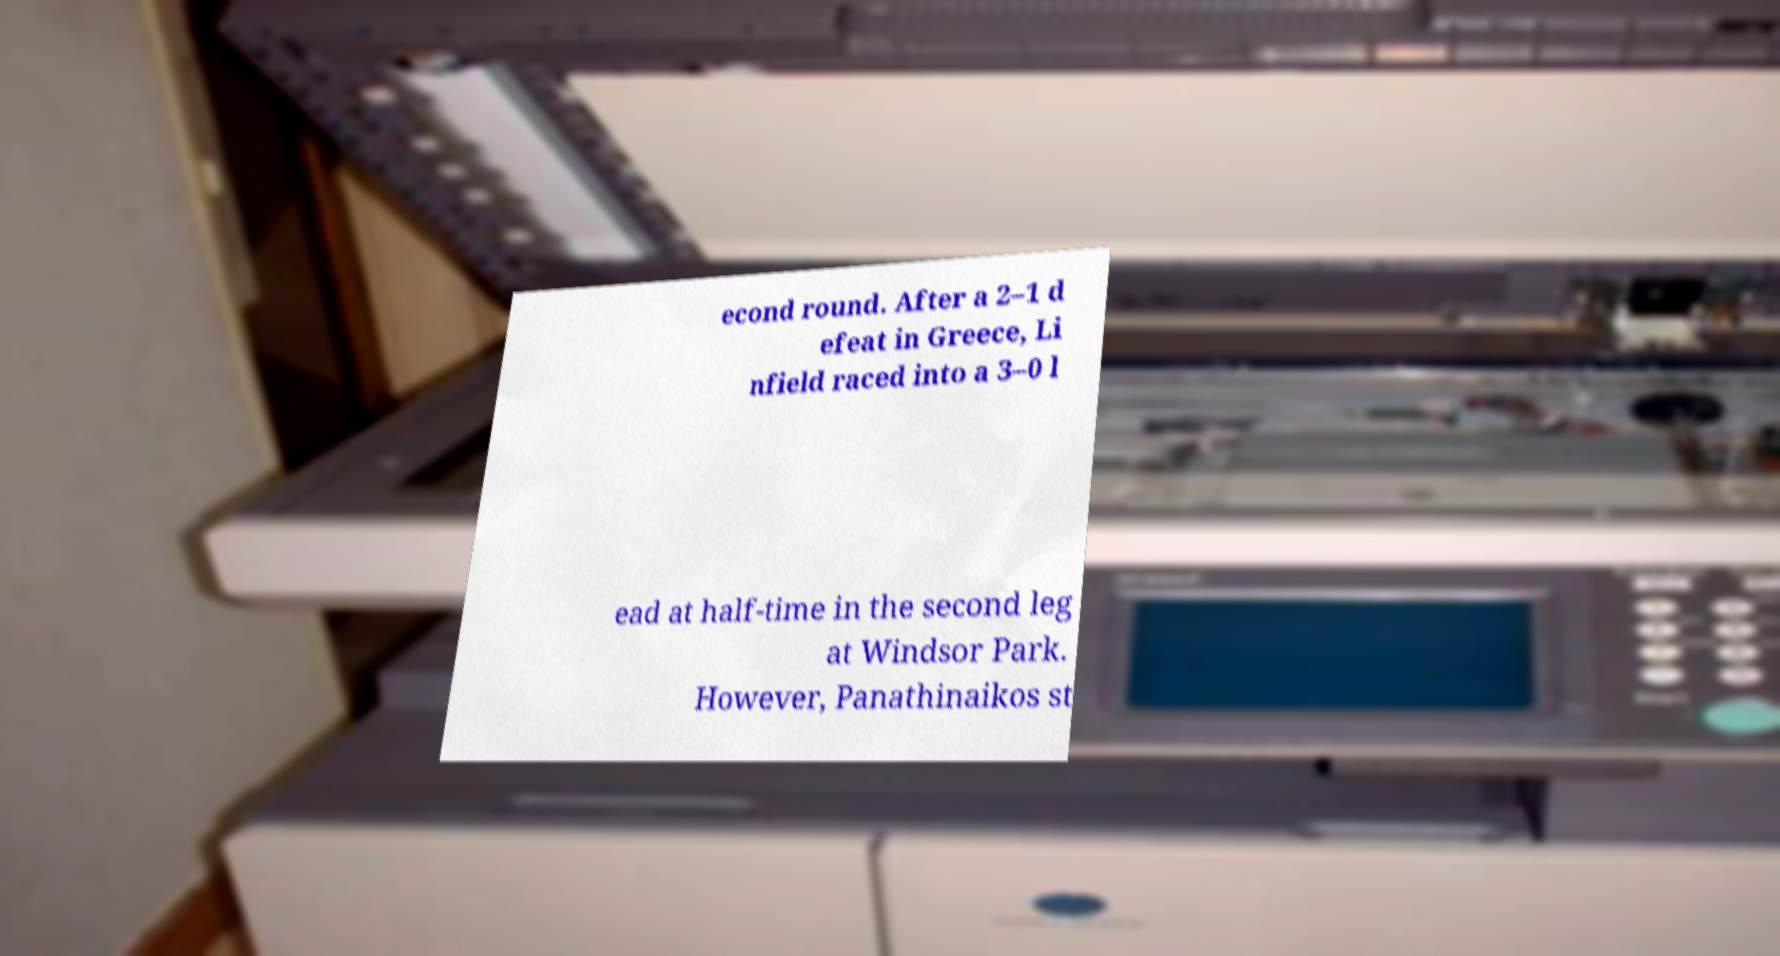Please identify and transcribe the text found in this image. econd round. After a 2–1 d efeat in Greece, Li nfield raced into a 3–0 l ead at half-time in the second leg at Windsor Park. However, Panathinaikos st 